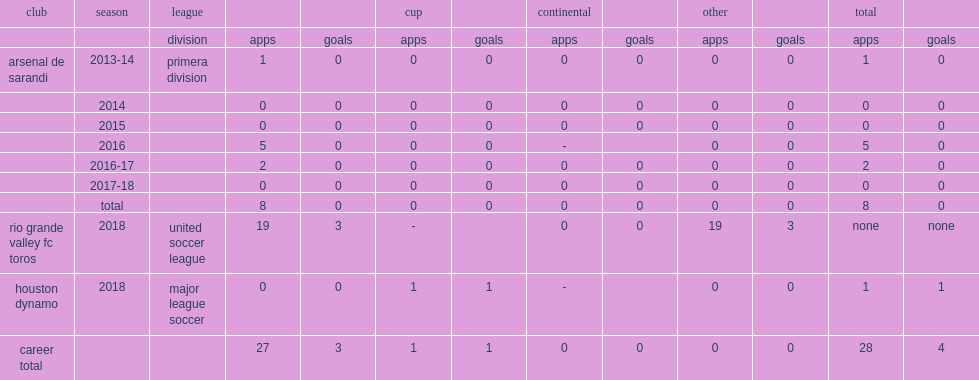In march 2018, which league did matias zaldivar of rio grande valley fc toros appear for? United soccer league. 